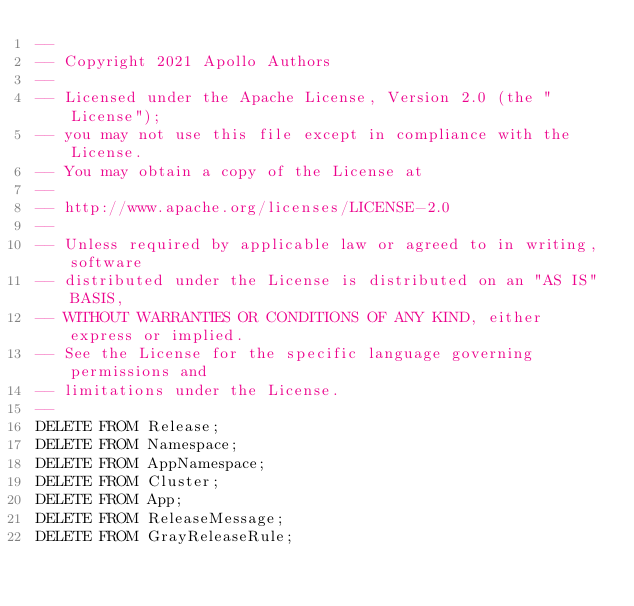<code> <loc_0><loc_0><loc_500><loc_500><_SQL_>--
-- Copyright 2021 Apollo Authors
--
-- Licensed under the Apache License, Version 2.0 (the "License");
-- you may not use this file except in compliance with the License.
-- You may obtain a copy of the License at
--
-- http://www.apache.org/licenses/LICENSE-2.0
--
-- Unless required by applicable law or agreed to in writing, software
-- distributed under the License is distributed on an "AS IS" BASIS,
-- WITHOUT WARRANTIES OR CONDITIONS OF ANY KIND, either express or implied.
-- See the License for the specific language governing permissions and
-- limitations under the License.
--
DELETE FROM Release;
DELETE FROM Namespace;
DELETE FROM AppNamespace;
DELETE FROM Cluster;
DELETE FROM App;
DELETE FROM ReleaseMessage;
DELETE FROM GrayReleaseRule;


</code> 